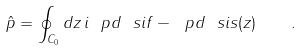Convert formula to latex. <formula><loc_0><loc_0><loc_500><loc_500>\hat { p } = \oint _ { C _ { 0 } } d z \, i \ p d \ s i f - \ p d \ s i s ( z ) \quad .</formula> 